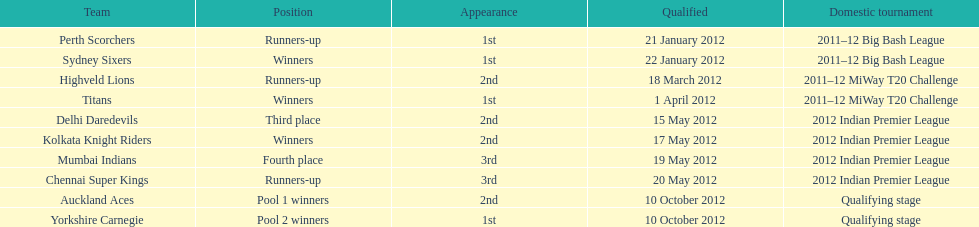Which game came in first in the 2012 indian premier league? Kolkata Knight Riders. 